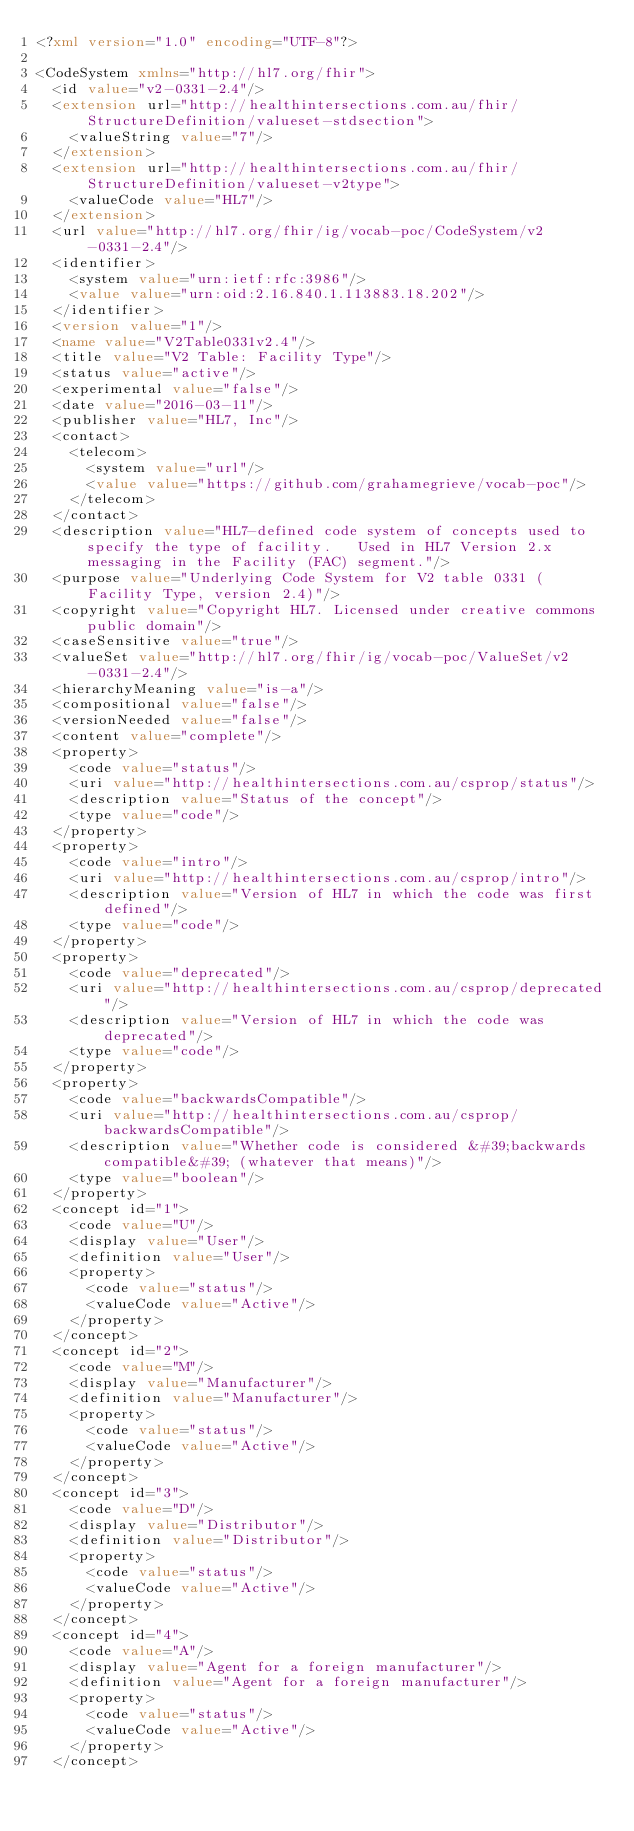Convert code to text. <code><loc_0><loc_0><loc_500><loc_500><_XML_><?xml version="1.0" encoding="UTF-8"?>

<CodeSystem xmlns="http://hl7.org/fhir">
  <id value="v2-0331-2.4"/>
  <extension url="http://healthintersections.com.au/fhir/StructureDefinition/valueset-stdsection">
    <valueString value="7"/>
  </extension>
  <extension url="http://healthintersections.com.au/fhir/StructureDefinition/valueset-v2type">
    <valueCode value="HL7"/>
  </extension>
  <url value="http://hl7.org/fhir/ig/vocab-poc/CodeSystem/v2-0331-2.4"/>
  <identifier>
    <system value="urn:ietf:rfc:3986"/>
    <value value="urn:oid:2.16.840.1.113883.18.202"/>
  </identifier>
  <version value="1"/>
  <name value="V2Table0331v2.4"/>
  <title value="V2 Table: Facility Type"/>
  <status value="active"/>
  <experimental value="false"/>
  <date value="2016-03-11"/>
  <publisher value="HL7, Inc"/>
  <contact>
    <telecom>
      <system value="url"/>
      <value value="https://github.com/grahamegrieve/vocab-poc"/>
    </telecom>
  </contact>
  <description value="HL7-defined code system of concepts used to specify the type of facility.   Used in HL7 Version 2.x messaging in the Facility (FAC) segment."/>
  <purpose value="Underlying Code System for V2 table 0331 (Facility Type, version 2.4)"/>
  <copyright value="Copyright HL7. Licensed under creative commons public domain"/>
  <caseSensitive value="true"/>
  <valueSet value="http://hl7.org/fhir/ig/vocab-poc/ValueSet/v2-0331-2.4"/>
  <hierarchyMeaning value="is-a"/>
  <compositional value="false"/>
  <versionNeeded value="false"/>
  <content value="complete"/>
  <property>
    <code value="status"/>
    <uri value="http://healthintersections.com.au/csprop/status"/>
    <description value="Status of the concept"/>
    <type value="code"/>
  </property>
  <property>
    <code value="intro"/>
    <uri value="http://healthintersections.com.au/csprop/intro"/>
    <description value="Version of HL7 in which the code was first defined"/>
    <type value="code"/>
  </property>
  <property>
    <code value="deprecated"/>
    <uri value="http://healthintersections.com.au/csprop/deprecated"/>
    <description value="Version of HL7 in which the code was deprecated"/>
    <type value="code"/>
  </property>
  <property>
    <code value="backwardsCompatible"/>
    <uri value="http://healthintersections.com.au/csprop/backwardsCompatible"/>
    <description value="Whether code is considered &#39;backwards compatible&#39; (whatever that means)"/>
    <type value="boolean"/>
  </property>
  <concept id="1">
    <code value="U"/>
    <display value="User"/>
    <definition value="User"/>
    <property>
      <code value="status"/>
      <valueCode value="Active"/>
    </property>
  </concept>
  <concept id="2">
    <code value="M"/>
    <display value="Manufacturer"/>
    <definition value="Manufacturer"/>
    <property>
      <code value="status"/>
      <valueCode value="Active"/>
    </property>
  </concept>
  <concept id="3">
    <code value="D"/>
    <display value="Distributor"/>
    <definition value="Distributor"/>
    <property>
      <code value="status"/>
      <valueCode value="Active"/>
    </property>
  </concept>
  <concept id="4">
    <code value="A"/>
    <display value="Agent for a foreign manufacturer"/>
    <definition value="Agent for a foreign manufacturer"/>
    <property>
      <code value="status"/>
      <valueCode value="Active"/>
    </property>
  </concept></code> 